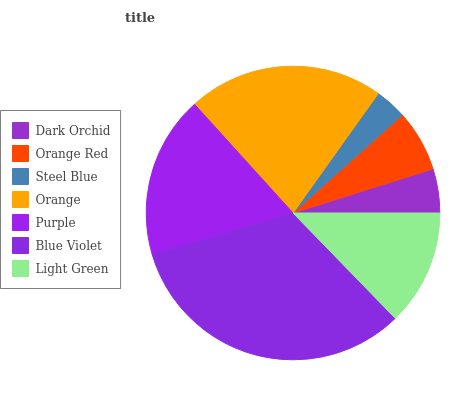Is Steel Blue the minimum?
Answer yes or no. Yes. Is Blue Violet the maximum?
Answer yes or no. Yes. Is Orange Red the minimum?
Answer yes or no. No. Is Orange Red the maximum?
Answer yes or no. No. Is Orange Red greater than Dark Orchid?
Answer yes or no. Yes. Is Dark Orchid less than Orange Red?
Answer yes or no. Yes. Is Dark Orchid greater than Orange Red?
Answer yes or no. No. Is Orange Red less than Dark Orchid?
Answer yes or no. No. Is Light Green the high median?
Answer yes or no. Yes. Is Light Green the low median?
Answer yes or no. Yes. Is Steel Blue the high median?
Answer yes or no. No. Is Steel Blue the low median?
Answer yes or no. No. 